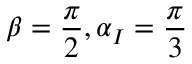<formula> <loc_0><loc_0><loc_500><loc_500>\beta = \frac { \pi } { 2 } , \alpha _ { I } = \frac { \pi } { 3 }</formula> 